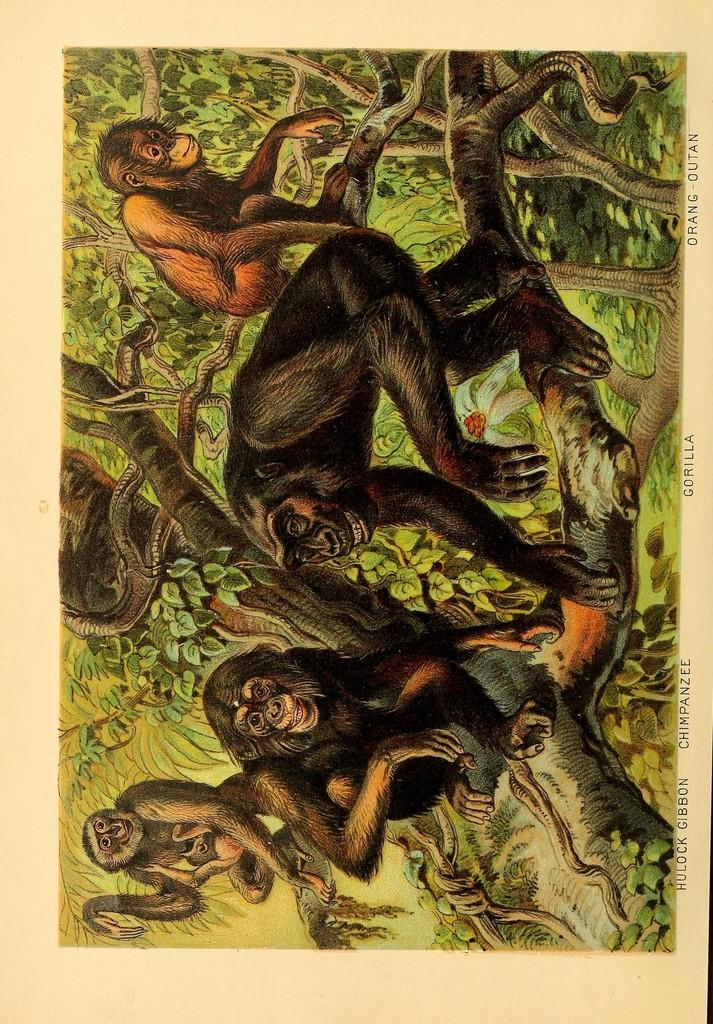What type of animals are in the image? There are monkeys in the image. What color are the monkeys? The monkeys are black in color. Where are the monkeys located in the image? The monkeys are sitting on the branches of trees. How many drawers are visible in the image? There are no drawers present in the image; it features black monkeys sitting on tree branches. What type of screw is being used by the monkeys in the image? There are no screws present in the image; it features black monkeys sitting on tree branches. 